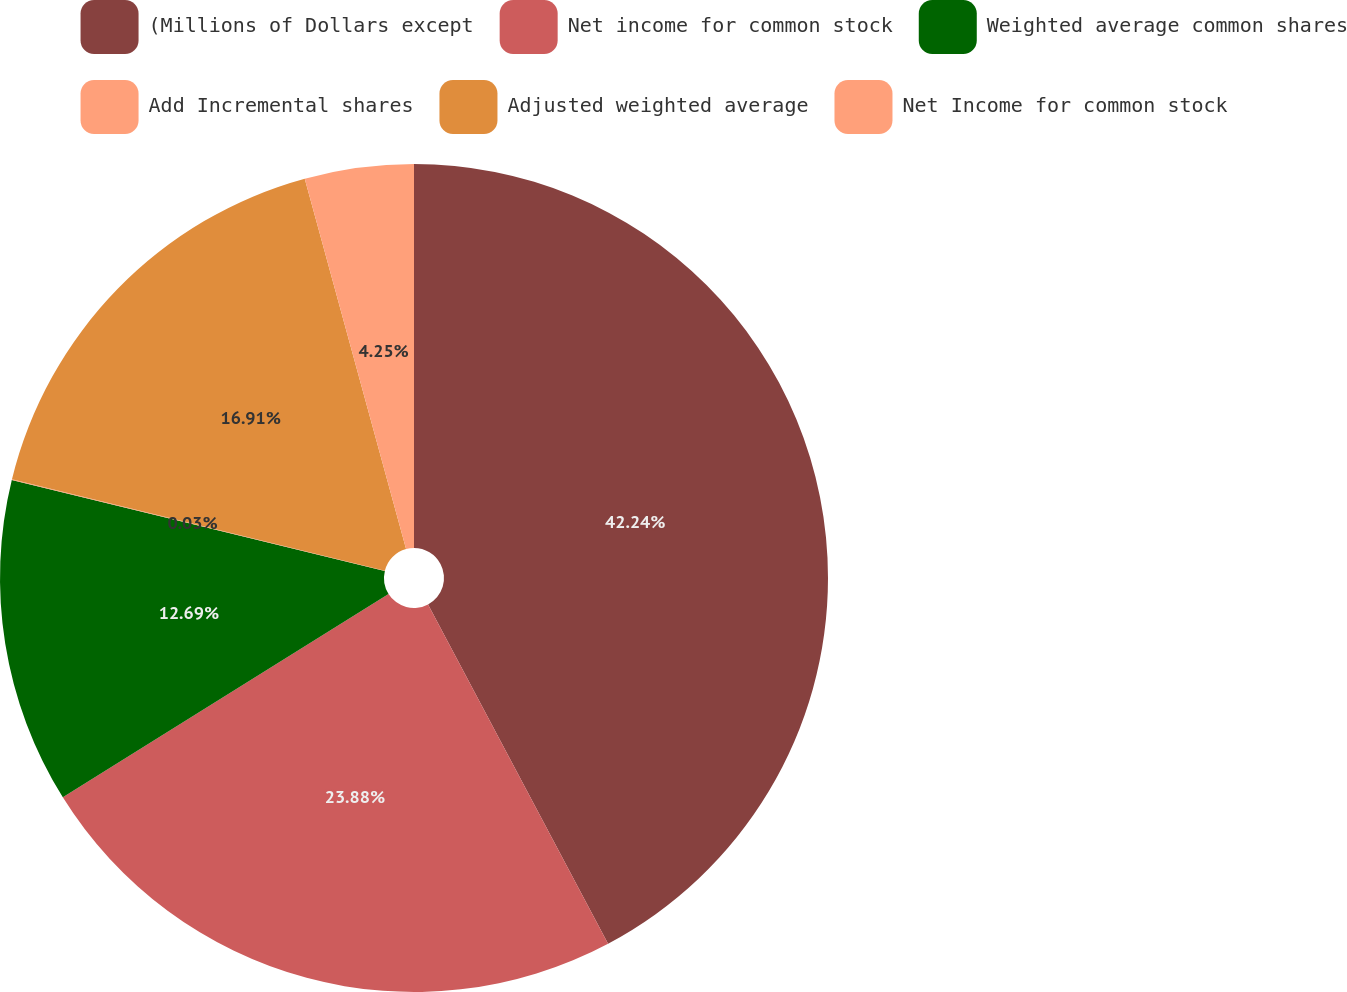<chart> <loc_0><loc_0><loc_500><loc_500><pie_chart><fcel>(Millions of Dollars except<fcel>Net income for common stock<fcel>Weighted average common shares<fcel>Add Incremental shares<fcel>Adjusted weighted average<fcel>Net Income for common stock<nl><fcel>42.23%<fcel>23.88%<fcel>12.69%<fcel>0.03%<fcel>16.91%<fcel>4.25%<nl></chart> 